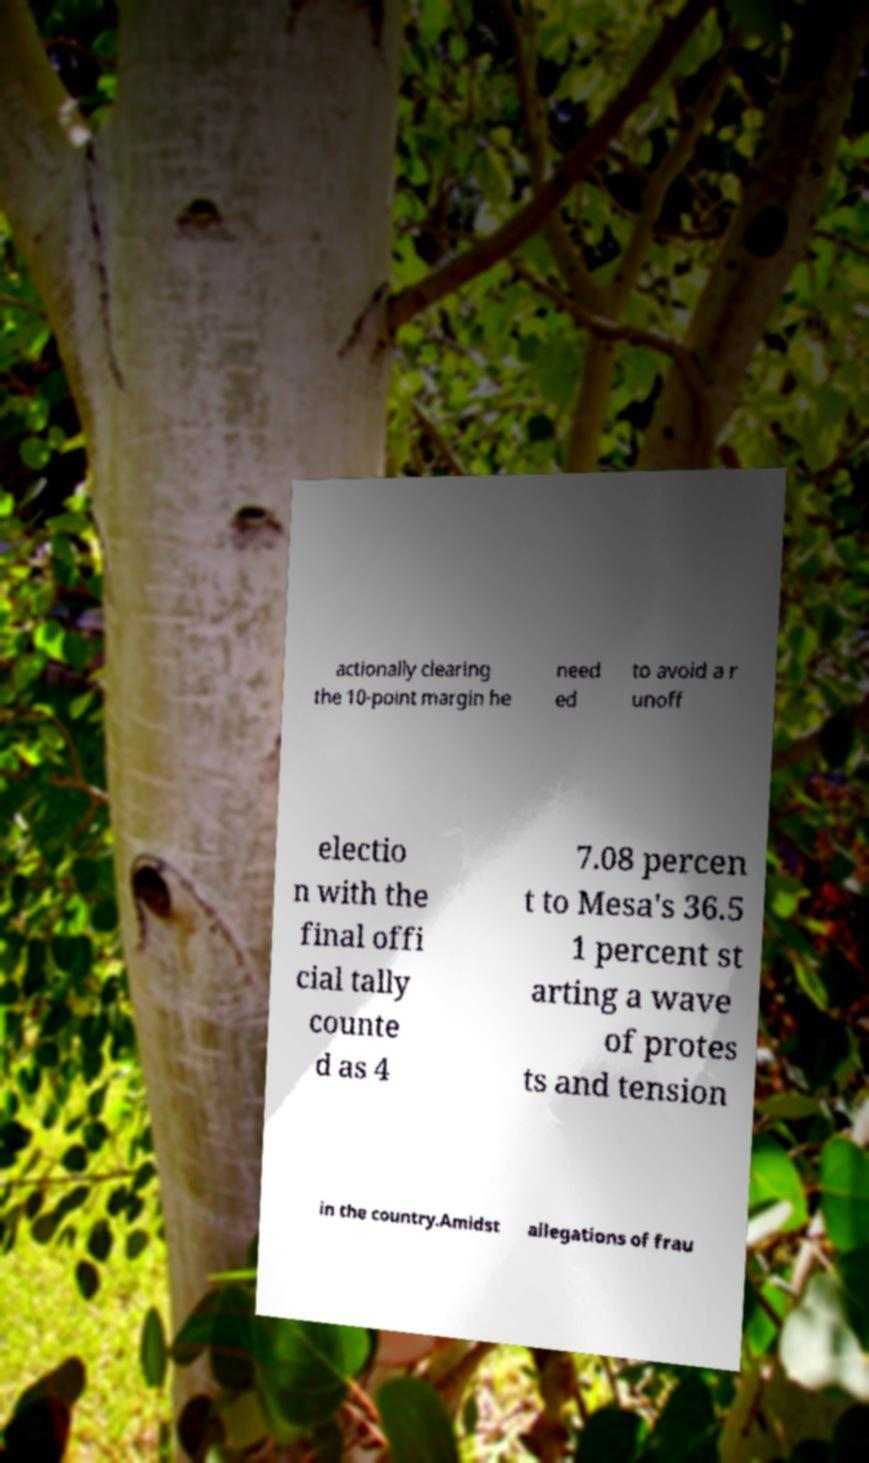Can you accurately transcribe the text from the provided image for me? actionally clearing the 10-point margin he need ed to avoid a r unoff electio n with the final offi cial tally counte d as 4 7.08 percen t to Mesa's 36.5 1 percent st arting a wave of protes ts and tension in the country.Amidst allegations of frau 